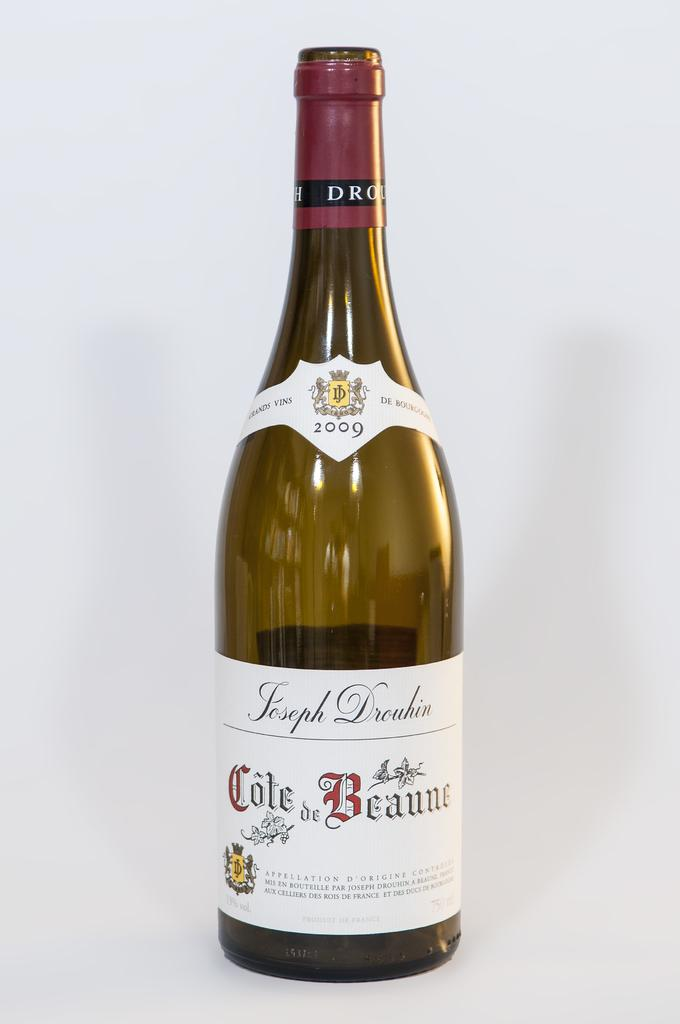Provide a one-sentence caption for the provided image. A bottle of 2009 Joseph Drouhin Cote de Beaune wine on a white background. 